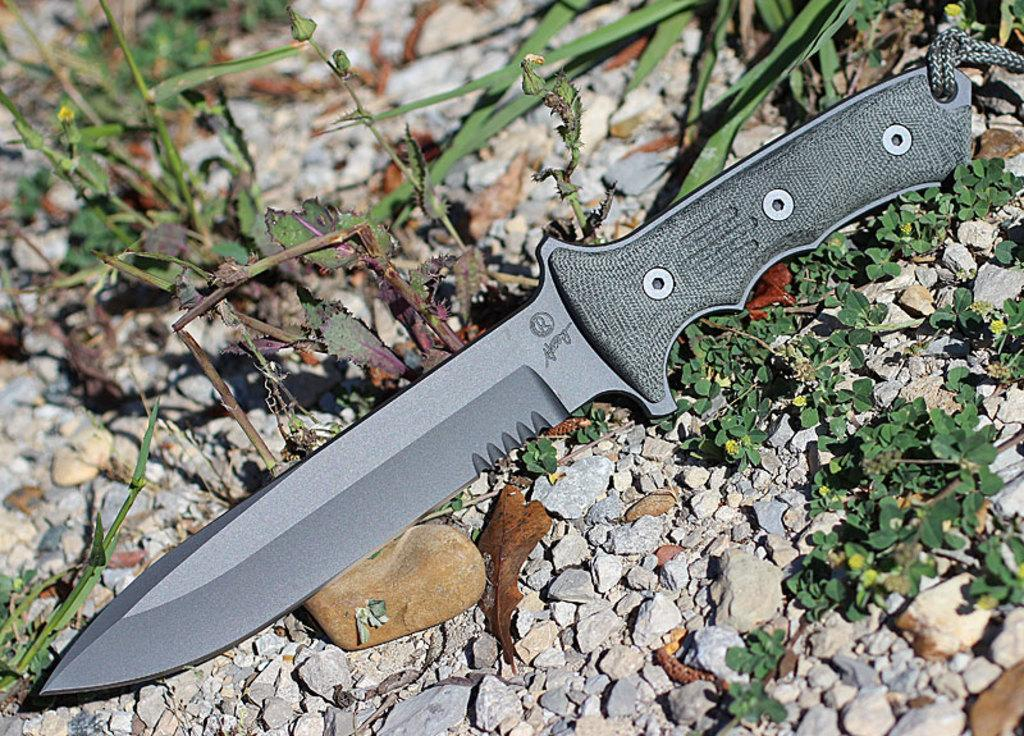What object is placed on a surface in the image? There is a knife on a surface in the image. What else is present near the knife? There is a group of stones around the knife. What type of vegetation can be seen in the image? There are plants in the image. What advice does the parent give to the child near the coast in the image? There is no parent, child, or coast present in the image. The image only features a knife, a group of stones, and plants. 